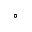Convert formula to latex. <formula><loc_0><loc_0><loc_500><loc_500>^ { \circ }</formula> 